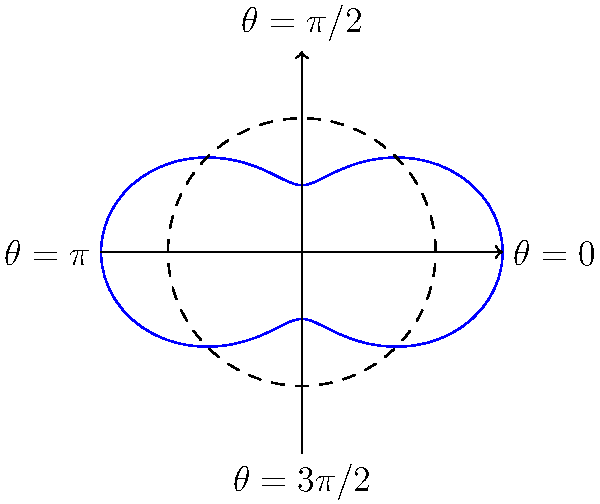In optimizing antenna radiation patterns for wireless communication systems, you're working with a polar equation $r(\theta) = 1 + 0.5\cos(2\theta)$. This represents the gain of an antenna in different directions. What is the maximum gain, and in which direction(s) does it occur? To find the maximum gain and its direction(s), we need to follow these steps:

1. Analyze the equation: $r(\theta) = 1 + 0.5\cos(2\theta)$
   The gain is represented by $r$, which varies with the angle $\theta$.

2. Determine the range of $\cos(2\theta)$:
   $-1 \leq \cos(2\theta) \leq 1$

3. Calculate the minimum and maximum values of $r(\theta)$:
   Min: $r_{min} = 1 + 0.5(-1) = 0.5$
   Max: $r_{max} = 1 + 0.5(1) = 1.5$

4. The maximum gain is 1.5.

5. To find the direction(s), solve for $\theta$ when $\cos(2\theta) = 1$:
   $2\theta = 0, 2\pi, 4\pi, ...$
   $\theta = 0, \pi, 2\pi, ...$

6. Convert to standard angle measures:
   $\theta = 0°$ and $\theta = 180°$

Therefore, the maximum gain occurs in two directions: along the positive x-axis ($\theta = 0°$) and the negative x-axis ($\theta = 180°$).

This result is consistent with the polar plot shown in the diagram, where the curve extends furthest from the origin at $\theta = 0$ and $\theta = \pi$.
Answer: Maximum gain: 1.5; Directions: $0°$ and $180°$ 